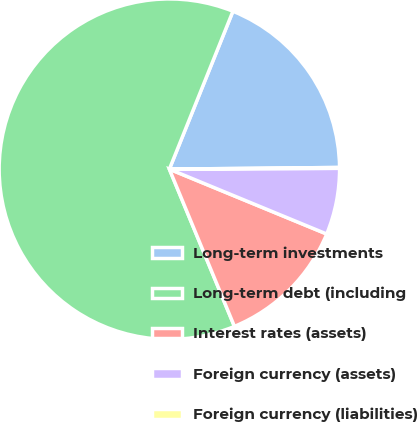Convert chart to OTSL. <chart><loc_0><loc_0><loc_500><loc_500><pie_chart><fcel>Long-term investments<fcel>Long-term debt (including<fcel>Interest rates (assets)<fcel>Foreign currency (assets)<fcel>Foreign currency (liabilities)<nl><fcel>18.75%<fcel>62.33%<fcel>12.53%<fcel>6.3%<fcel>0.08%<nl></chart> 